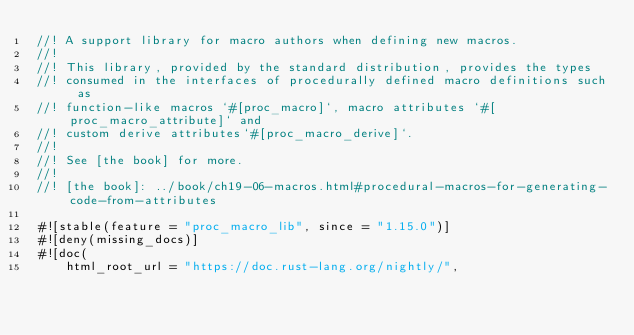<code> <loc_0><loc_0><loc_500><loc_500><_Rust_>//! A support library for macro authors when defining new macros.
//!
//! This library, provided by the standard distribution, provides the types
//! consumed in the interfaces of procedurally defined macro definitions such as
//! function-like macros `#[proc_macro]`, macro attributes `#[proc_macro_attribute]` and
//! custom derive attributes`#[proc_macro_derive]`.
//!
//! See [the book] for more.
//!
//! [the book]: ../book/ch19-06-macros.html#procedural-macros-for-generating-code-from-attributes

#![stable(feature = "proc_macro_lib", since = "1.15.0")]
#![deny(missing_docs)]
#![doc(
    html_root_url = "https://doc.rust-lang.org/nightly/",</code> 